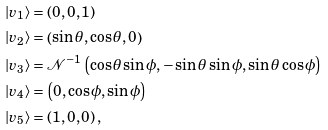<formula> <loc_0><loc_0><loc_500><loc_500>| v _ { 1 } \rangle & = \left ( 0 , 0 , 1 \right ) \\ | v _ { 2 } \rangle & = \left ( \sin \theta , \cos \theta , 0 \right ) \\ | v _ { 3 } \rangle & = \mathcal { N } ^ { - 1 } \left ( \cos \theta \sin \phi , - \sin \theta \sin \phi , \sin \theta \cos \phi \right ) \\ | v _ { 4 } \rangle & = \left ( 0 , \cos \phi , \sin \phi \right ) \\ | v _ { 5 } \rangle & = \left ( 1 , 0 , 0 \right ) ,</formula> 